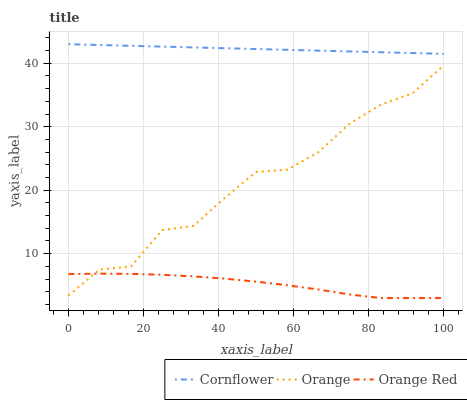Does Orange Red have the minimum area under the curve?
Answer yes or no. Yes. Does Cornflower have the maximum area under the curve?
Answer yes or no. Yes. Does Cornflower have the minimum area under the curve?
Answer yes or no. No. Does Orange Red have the maximum area under the curve?
Answer yes or no. No. Is Cornflower the smoothest?
Answer yes or no. Yes. Is Orange the roughest?
Answer yes or no. Yes. Is Orange Red the smoothest?
Answer yes or no. No. Is Orange Red the roughest?
Answer yes or no. No. Does Orange Red have the lowest value?
Answer yes or no. Yes. Does Cornflower have the lowest value?
Answer yes or no. No. Does Cornflower have the highest value?
Answer yes or no. Yes. Does Orange Red have the highest value?
Answer yes or no. No. Is Orange less than Cornflower?
Answer yes or no. Yes. Is Cornflower greater than Orange Red?
Answer yes or no. Yes. Does Orange intersect Orange Red?
Answer yes or no. Yes. Is Orange less than Orange Red?
Answer yes or no. No. Is Orange greater than Orange Red?
Answer yes or no. No. Does Orange intersect Cornflower?
Answer yes or no. No. 